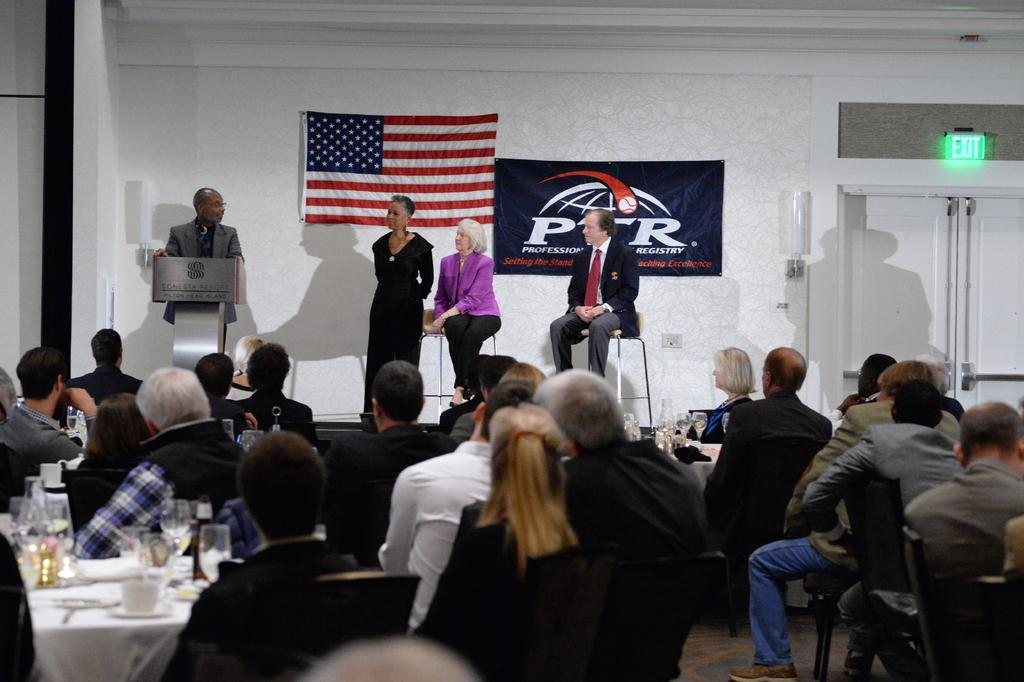What is the main subject of the image? The main subject of the image is a group of people. What is the man at the podium doing? The man is standing at a podium and speaking to the group of people. How many people are on the stage with the man? There are three other people standing beside the man on the stage. Can you see the man's friend sleeping by the river in the image? There is no friend or river present in the image; it features a man at a podium speaking to a group of people. 